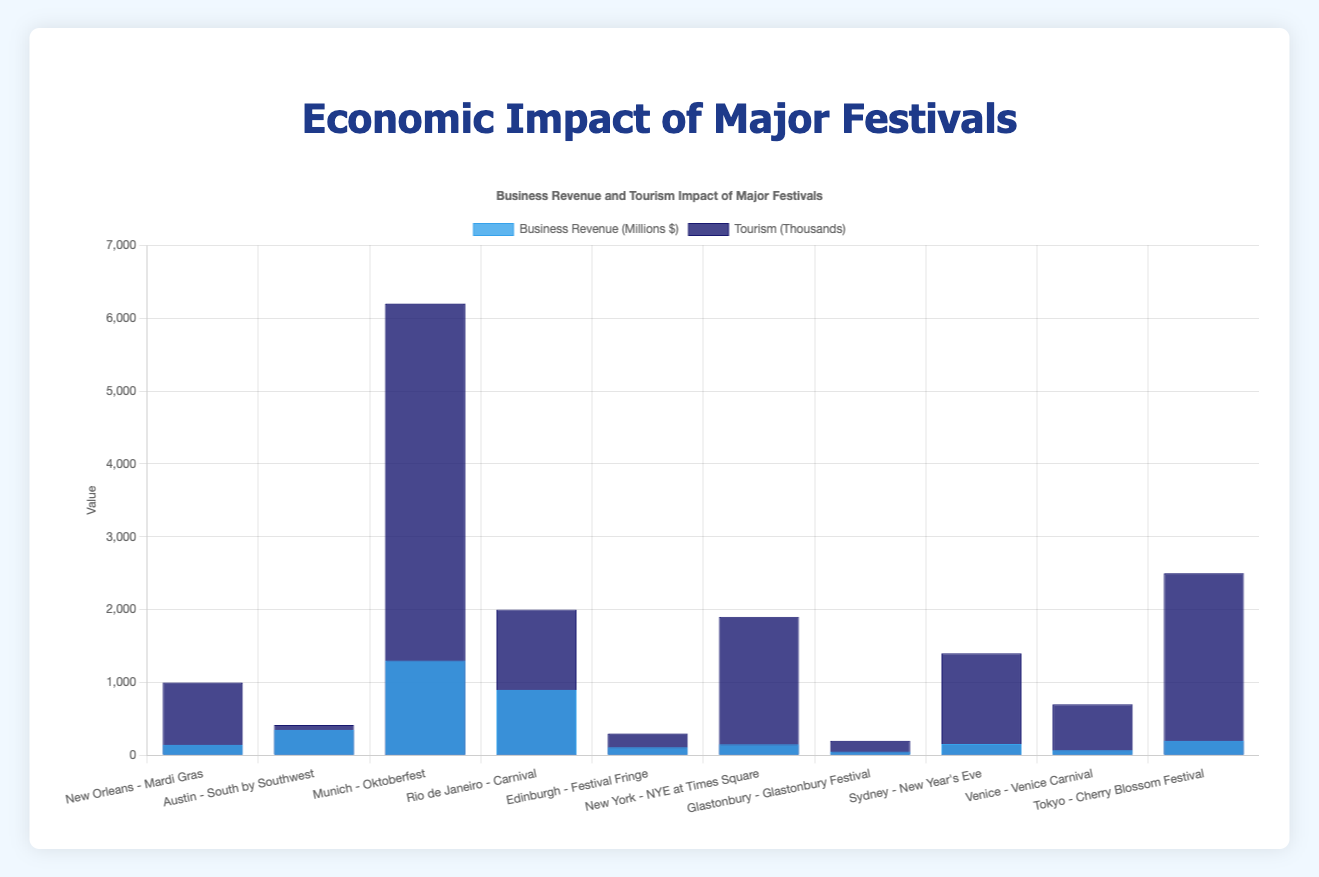Which city generates the highest business revenue from its festival? The bar representing Munich - Oktoberfest is the tallest among all bars in the "Business Revenue (Millions $)" dataset, indicating the highest revenue.
Answer: Munich Which festival attracts more tourists, Venice Carnival or Sydney New Year's Eve? The bar for tourism of Sydney New Year's Eve is taller than that of Venice Carnival in the tourism dataset.
Answer: Sydney New Year's Eve What is the combined business revenue for Mardi Gras in New Orleans and New Year's Eve at Times Square in New York? The business revenue for Mardi Gras is 145 million dollars, and for New Year's Eve at Times Square, it's 150 million dollars. Summing these values, 145 + 150 = 295 million dollars.
Answer: 295 million dollars Which city has the lowest business revenue generated from its festival? The bar representing Glastonbury - Glastonbury Festival in the "Business Revenue" dataset is the shortest, indicating the lowest revenue.
Answer: Glastonbury Compare the employment impacts of Carnival in Rio de Janeiro and Festival Fringe in Edinburgh. Which festival provides more jobs? The bar for employment in Rio de Janeiro - Carnival is significantly taller than that for Edinburgh - Festival Fringe, indicating higher employment.
Answer: Rio de Janeiro How much more tourism did the Cherry Blossom Festival in Tokyo generate compared to South by Southwest in Austin? Cherry Blossom Festival attracted 2500 thousand tourists while South by Southwest attracted 417 thousand. The difference is 2500 - 417 = 2083 thousand tourists.
Answer: 2083 thousand tourists Which has a greater impact in terms of business revenue: Mardi Gras in New Orleans or Sydney New Year's Eve? The business revenue from Sydney New Year's Eve (155 million dollars) is slightly greater than that of Mardi Gras (145 million dollars), as shown by the height of their respective bars.
Answer: Sydney New Year's Eve What is the total employment contribution from Oktoberfest in Munich and the Cherry Blossom Festival in Tokyo? Employment contributions from Munich (Oktoberfest) and Tokyo (Cherry Blossom Festival) are 13000 and 2000 jobs respectively. Summing these, 13000 + 2000 = 15000 jobs.
Answer: 15000 jobs 